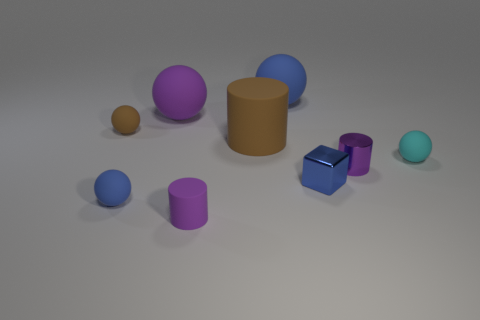Are there any small blue spheres behind the small blue metallic block? After carefully examining the image, there doesn't appear to be any small blue spheres located directly behind the small blue metallic block. The background contains a variety of other shapes and colors, but the specific objects in question are not present in that area. 